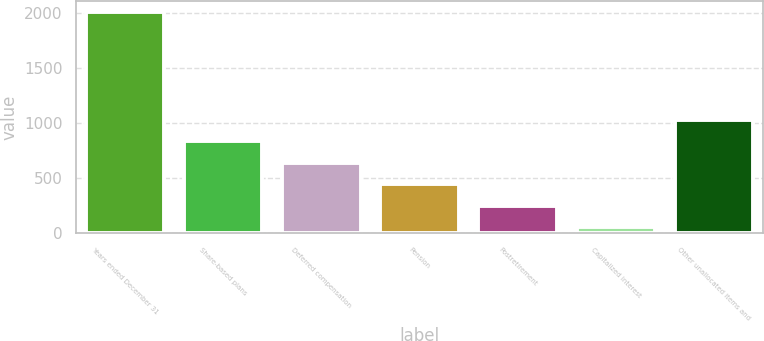<chart> <loc_0><loc_0><loc_500><loc_500><bar_chart><fcel>Years ended December 31<fcel>Share-based plans<fcel>Deferred compensation<fcel>Pension<fcel>Postretirement<fcel>Capitalized interest<fcel>Other unallocated items and<nl><fcel>2009<fcel>835.4<fcel>639.8<fcel>444.2<fcel>248.6<fcel>53<fcel>1031<nl></chart> 